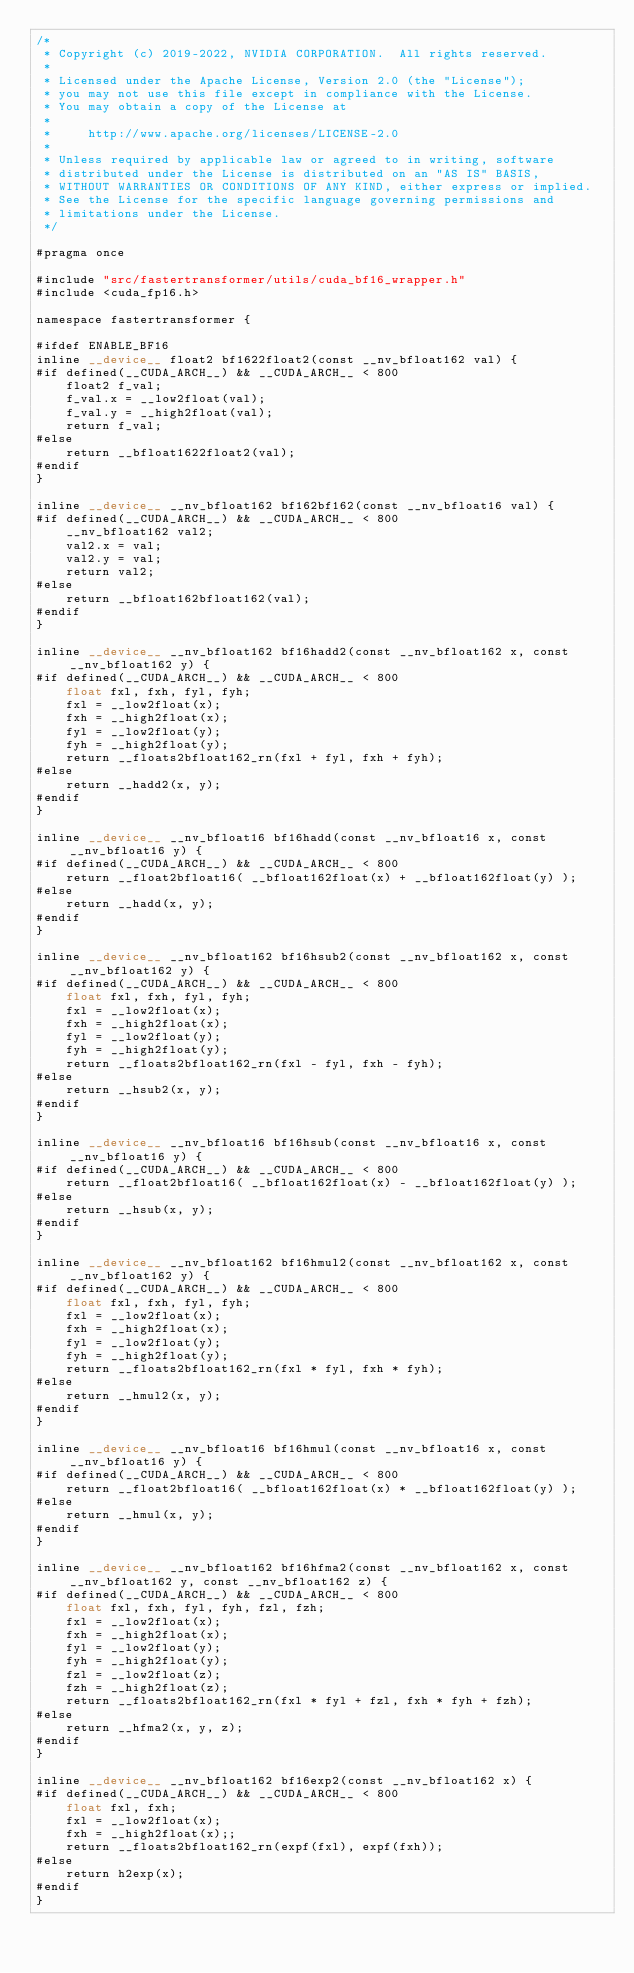<code> <loc_0><loc_0><loc_500><loc_500><_Cuda_>/*
 * Copyright (c) 2019-2022, NVIDIA CORPORATION.  All rights reserved.
 *
 * Licensed under the Apache License, Version 2.0 (the "License");
 * you may not use this file except in compliance with the License.
 * You may obtain a copy of the License at
 *
 *     http://www.apache.org/licenses/LICENSE-2.0
 *
 * Unless required by applicable law or agreed to in writing, software
 * distributed under the License is distributed on an "AS IS" BASIS,
 * WITHOUT WARRANTIES OR CONDITIONS OF ANY KIND, either express or implied.
 * See the License for the specific language governing permissions and
 * limitations under the License.
 */

#pragma once

#include "src/fastertransformer/utils/cuda_bf16_wrapper.h"
#include <cuda_fp16.h>

namespace fastertransformer {

#ifdef ENABLE_BF16
inline __device__ float2 bf1622float2(const __nv_bfloat162 val) {
#if defined(__CUDA_ARCH__) && __CUDA_ARCH__ < 800
    float2 f_val;
    f_val.x = __low2float(val); 
    f_val.y = __high2float(val);
    return f_val;
#else
    return __bfloat1622float2(val);
#endif
}

inline __device__ __nv_bfloat162 bf162bf162(const __nv_bfloat16 val) {
#if defined(__CUDA_ARCH__) && __CUDA_ARCH__ < 800
    __nv_bfloat162 val2;
    val2.x = val;
    val2.y = val;
    return val2;
#else
    return __bfloat162bfloat162(val);
#endif
}

inline __device__ __nv_bfloat162 bf16hadd2(const __nv_bfloat162 x, const __nv_bfloat162 y) {
#if defined(__CUDA_ARCH__) && __CUDA_ARCH__ < 800
    float fxl, fxh, fyl, fyh;
    fxl = __low2float(x);
    fxh = __high2float(x);
    fyl = __low2float(y);
    fyh = __high2float(y);
    return __floats2bfloat162_rn(fxl + fyl, fxh + fyh);
#else
    return __hadd2(x, y);
#endif
}

inline __device__ __nv_bfloat16 bf16hadd(const __nv_bfloat16 x, const __nv_bfloat16 y) {
#if defined(__CUDA_ARCH__) && __CUDA_ARCH__ < 800
    return __float2bfloat16( __bfloat162float(x) + __bfloat162float(y) );
#else
    return __hadd(x, y);
#endif
}

inline __device__ __nv_bfloat162 bf16hsub2(const __nv_bfloat162 x, const __nv_bfloat162 y) {
#if defined(__CUDA_ARCH__) && __CUDA_ARCH__ < 800
    float fxl, fxh, fyl, fyh;
    fxl = __low2float(x);
    fxh = __high2float(x);
    fyl = __low2float(y);
    fyh = __high2float(y);
    return __floats2bfloat162_rn(fxl - fyl, fxh - fyh);
#else
    return __hsub2(x, y);
#endif
}

inline __device__ __nv_bfloat16 bf16hsub(const __nv_bfloat16 x, const __nv_bfloat16 y) {
#if defined(__CUDA_ARCH__) && __CUDA_ARCH__ < 800
    return __float2bfloat16( __bfloat162float(x) - __bfloat162float(y) );
#else
    return __hsub(x, y);
#endif
}

inline __device__ __nv_bfloat162 bf16hmul2(const __nv_bfloat162 x, const __nv_bfloat162 y) {
#if defined(__CUDA_ARCH__) && __CUDA_ARCH__ < 800
    float fxl, fxh, fyl, fyh;
    fxl = __low2float(x);
    fxh = __high2float(x);
    fyl = __low2float(y);
    fyh = __high2float(y);
    return __floats2bfloat162_rn(fxl * fyl, fxh * fyh);
#else
    return __hmul2(x, y);
#endif
}

inline __device__ __nv_bfloat16 bf16hmul(const __nv_bfloat16 x, const __nv_bfloat16 y) {
#if defined(__CUDA_ARCH__) && __CUDA_ARCH__ < 800
    return __float2bfloat16( __bfloat162float(x) * __bfloat162float(y) );
#else 
    return __hmul(x, y);
#endif
}

inline __device__ __nv_bfloat162 bf16hfma2(const __nv_bfloat162 x, const __nv_bfloat162 y, const __nv_bfloat162 z) {
#if defined(__CUDA_ARCH__) && __CUDA_ARCH__ < 800
    float fxl, fxh, fyl, fyh, fzl, fzh;
    fxl = __low2float(x);
    fxh = __high2float(x);
    fyl = __low2float(y);
    fyh = __high2float(y);
    fzl = __low2float(z);
    fzh = __high2float(z);
    return __floats2bfloat162_rn(fxl * fyl + fzl, fxh * fyh + fzh);
#else
    return __hfma2(x, y, z);
#endif
}

inline __device__ __nv_bfloat162 bf16exp2(const __nv_bfloat162 x) {
#if defined(__CUDA_ARCH__) && __CUDA_ARCH__ < 800
    float fxl, fxh;
    fxl = __low2float(x);
    fxh = __high2float(x);;
    return __floats2bfloat162_rn(expf(fxl), expf(fxh));
#else
    return h2exp(x);
#endif
}</code> 